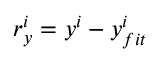Convert formula to latex. <formula><loc_0><loc_0><loc_500><loc_500>r _ { y } ^ { i } = y ^ { i } - y _ { f i t } ^ { i }</formula> 